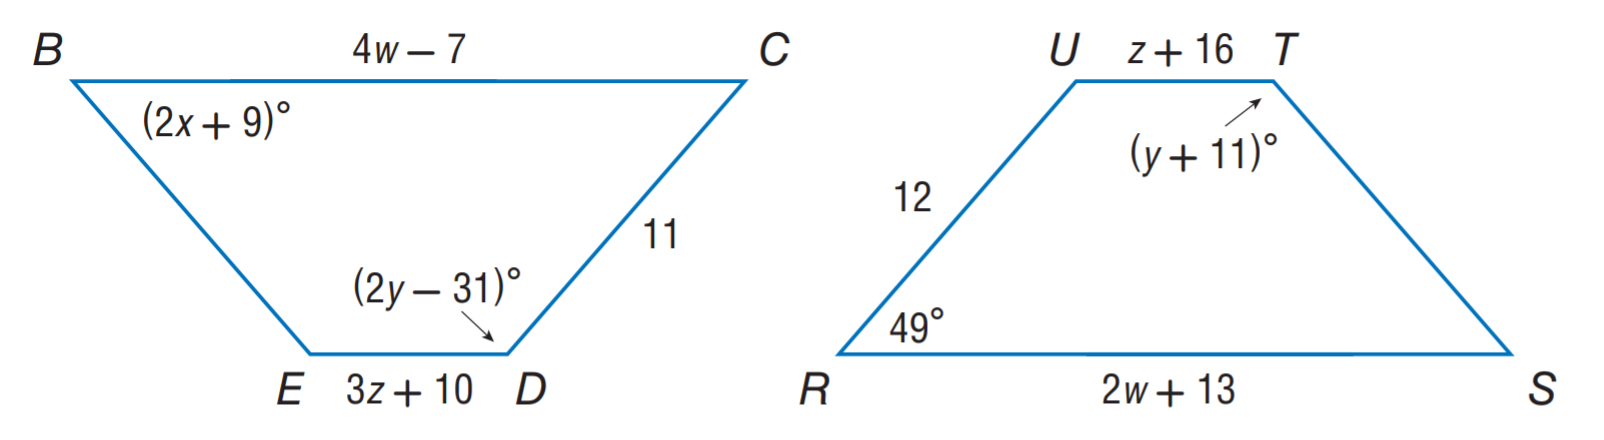Answer the mathemtical geometry problem and directly provide the correct option letter.
Question: Polygon B C D E \cong polygon R S T U. Find y.
Choices: A: 3 B: 10 C: 20 D: 42 D 